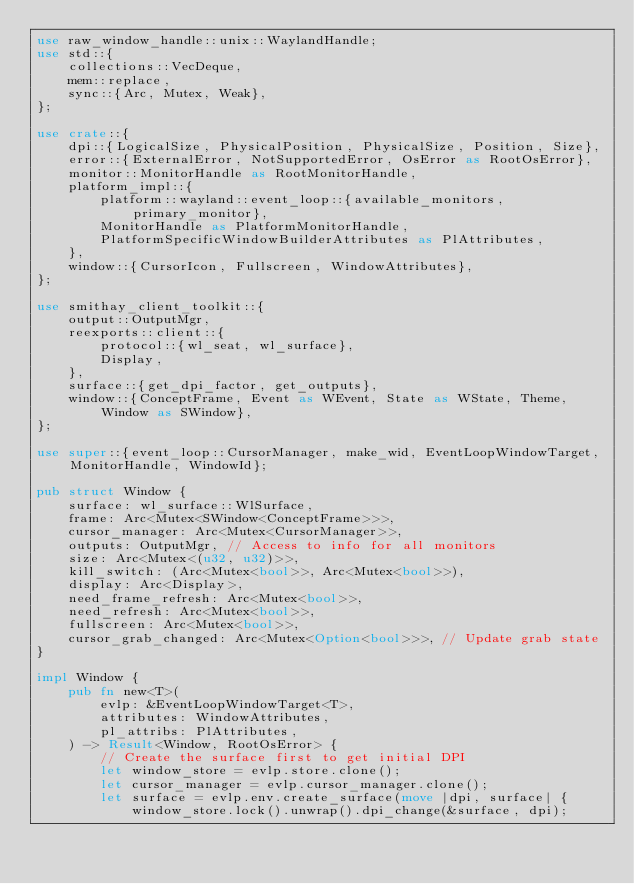<code> <loc_0><loc_0><loc_500><loc_500><_Rust_>use raw_window_handle::unix::WaylandHandle;
use std::{
    collections::VecDeque,
    mem::replace,
    sync::{Arc, Mutex, Weak},
};

use crate::{
    dpi::{LogicalSize, PhysicalPosition, PhysicalSize, Position, Size},
    error::{ExternalError, NotSupportedError, OsError as RootOsError},
    monitor::MonitorHandle as RootMonitorHandle,
    platform_impl::{
        platform::wayland::event_loop::{available_monitors, primary_monitor},
        MonitorHandle as PlatformMonitorHandle,
        PlatformSpecificWindowBuilderAttributes as PlAttributes,
    },
    window::{CursorIcon, Fullscreen, WindowAttributes},
};

use smithay_client_toolkit::{
    output::OutputMgr,
    reexports::client::{
        protocol::{wl_seat, wl_surface},
        Display,
    },
    surface::{get_dpi_factor, get_outputs},
    window::{ConceptFrame, Event as WEvent, State as WState, Theme, Window as SWindow},
};

use super::{event_loop::CursorManager, make_wid, EventLoopWindowTarget, MonitorHandle, WindowId};

pub struct Window {
    surface: wl_surface::WlSurface,
    frame: Arc<Mutex<SWindow<ConceptFrame>>>,
    cursor_manager: Arc<Mutex<CursorManager>>,
    outputs: OutputMgr, // Access to info for all monitors
    size: Arc<Mutex<(u32, u32)>>,
    kill_switch: (Arc<Mutex<bool>>, Arc<Mutex<bool>>),
    display: Arc<Display>,
    need_frame_refresh: Arc<Mutex<bool>>,
    need_refresh: Arc<Mutex<bool>>,
    fullscreen: Arc<Mutex<bool>>,
    cursor_grab_changed: Arc<Mutex<Option<bool>>>, // Update grab state
}

impl Window {
    pub fn new<T>(
        evlp: &EventLoopWindowTarget<T>,
        attributes: WindowAttributes,
        pl_attribs: PlAttributes,
    ) -> Result<Window, RootOsError> {
        // Create the surface first to get initial DPI
        let window_store = evlp.store.clone();
        let cursor_manager = evlp.cursor_manager.clone();
        let surface = evlp.env.create_surface(move |dpi, surface| {
            window_store.lock().unwrap().dpi_change(&surface, dpi);</code> 